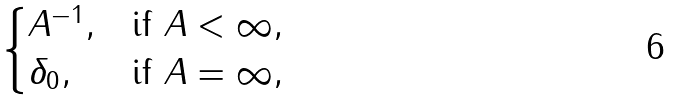Convert formula to latex. <formula><loc_0><loc_0><loc_500><loc_500>\begin{cases} A ^ { - 1 } , & \text {if } A < \infty , \\ \delta _ { 0 } , & \text {if } A = \infty , \end{cases}</formula> 